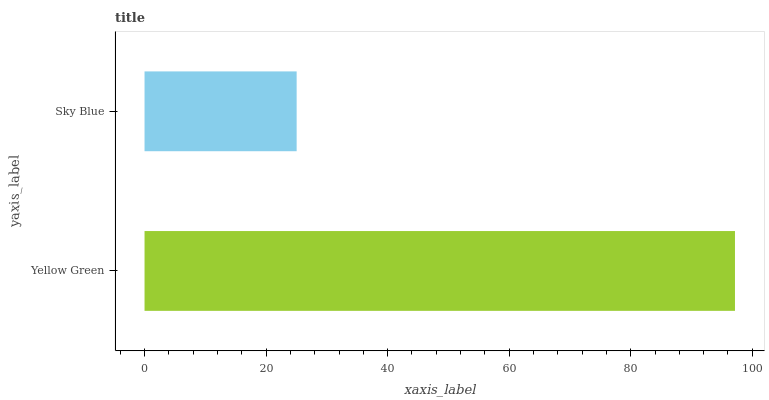Is Sky Blue the minimum?
Answer yes or no. Yes. Is Yellow Green the maximum?
Answer yes or no. Yes. Is Sky Blue the maximum?
Answer yes or no. No. Is Yellow Green greater than Sky Blue?
Answer yes or no. Yes. Is Sky Blue less than Yellow Green?
Answer yes or no. Yes. Is Sky Blue greater than Yellow Green?
Answer yes or no. No. Is Yellow Green less than Sky Blue?
Answer yes or no. No. Is Yellow Green the high median?
Answer yes or no. Yes. Is Sky Blue the low median?
Answer yes or no. Yes. Is Sky Blue the high median?
Answer yes or no. No. Is Yellow Green the low median?
Answer yes or no. No. 